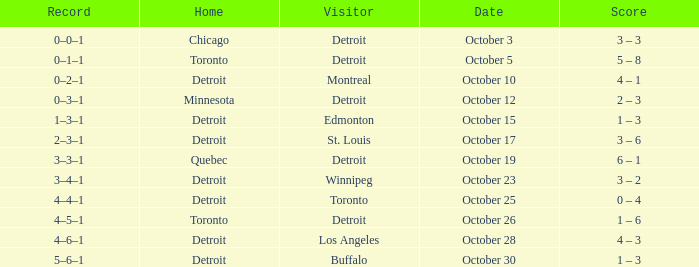Name the home with toronto visiting Detroit. 